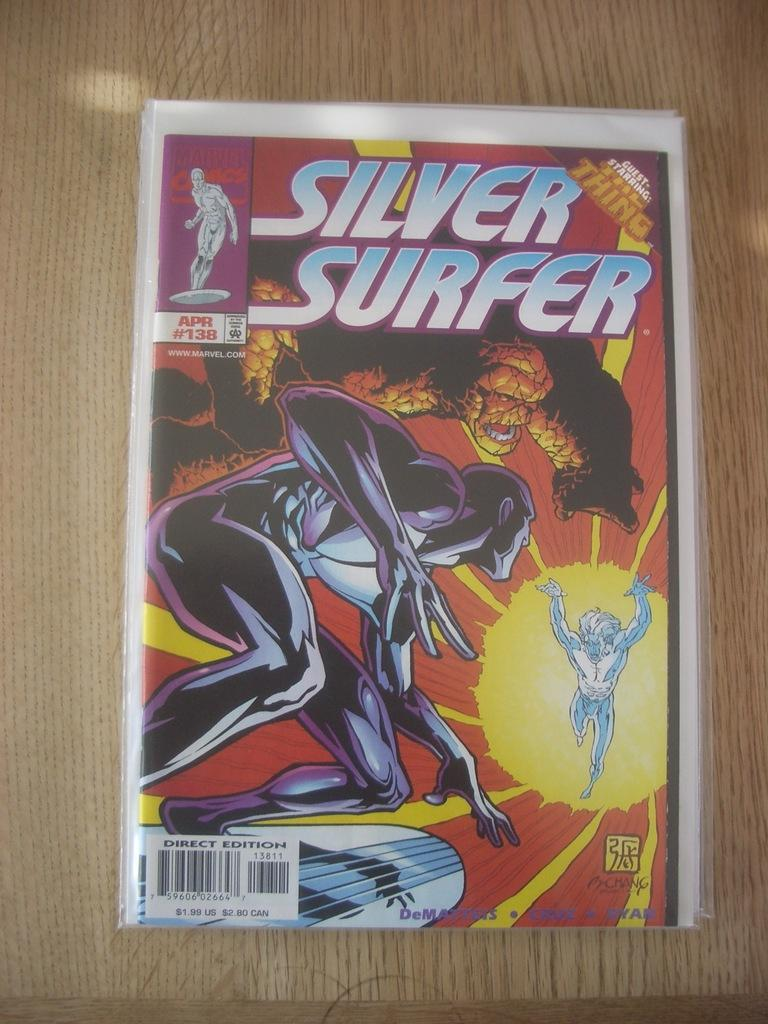Provide a one-sentence caption for the provided image. an issue of the silver surfer april #138. 